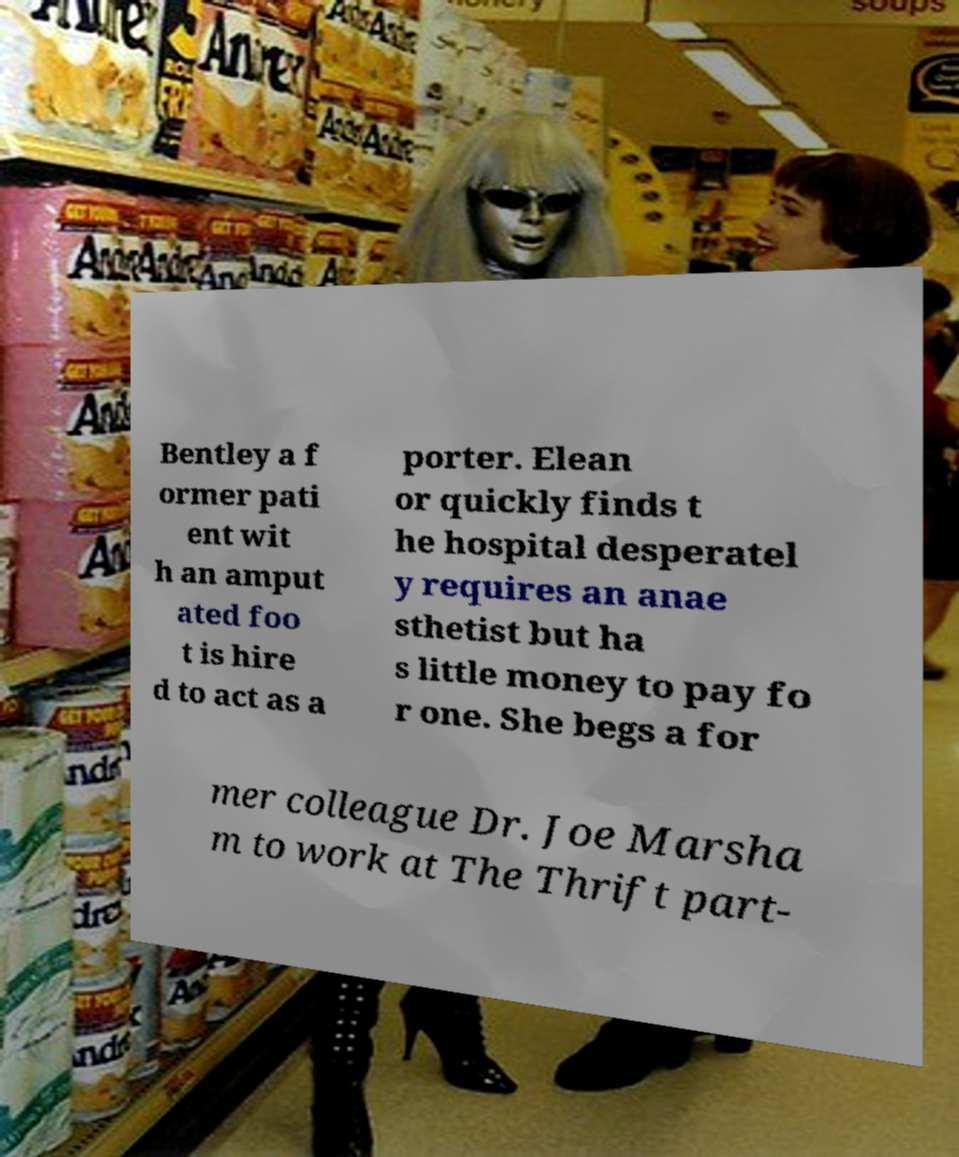Can you read and provide the text displayed in the image?This photo seems to have some interesting text. Can you extract and type it out for me? Bentley a f ormer pati ent wit h an amput ated foo t is hire d to act as a porter. Elean or quickly finds t he hospital desperatel y requires an anae sthetist but ha s little money to pay fo r one. She begs a for mer colleague Dr. Joe Marsha m to work at The Thrift part- 